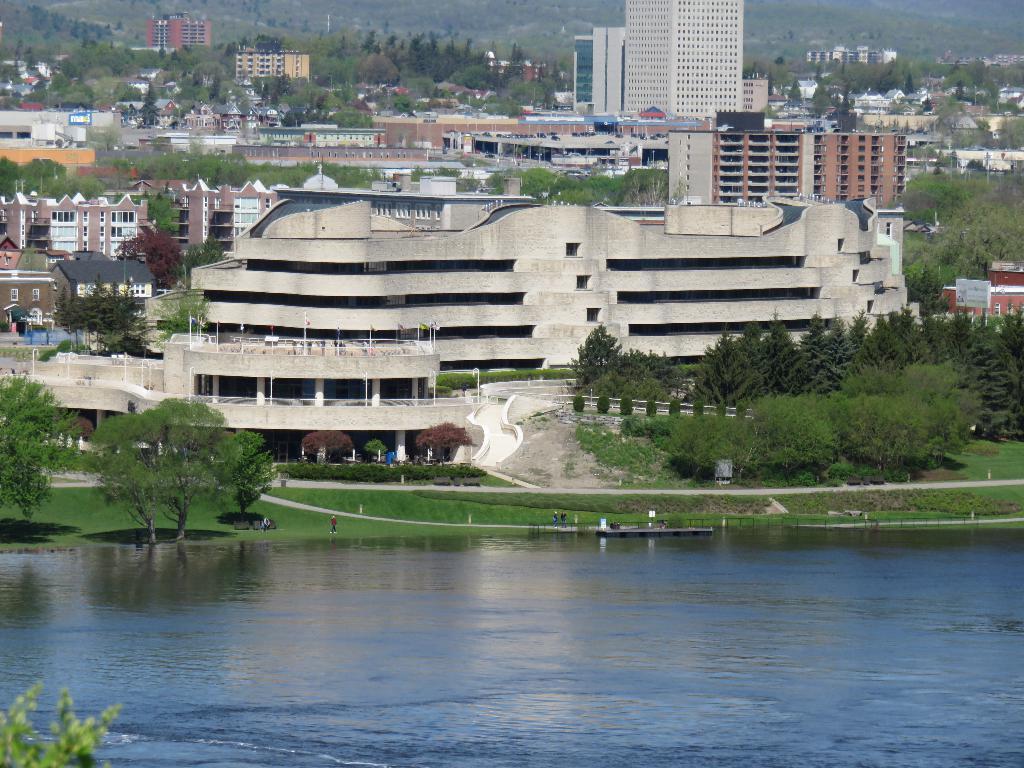How would you summarize this image in a sentence or two? In this picture I can see the lake, side we can see some trees, grass and we can see so many buildings. 